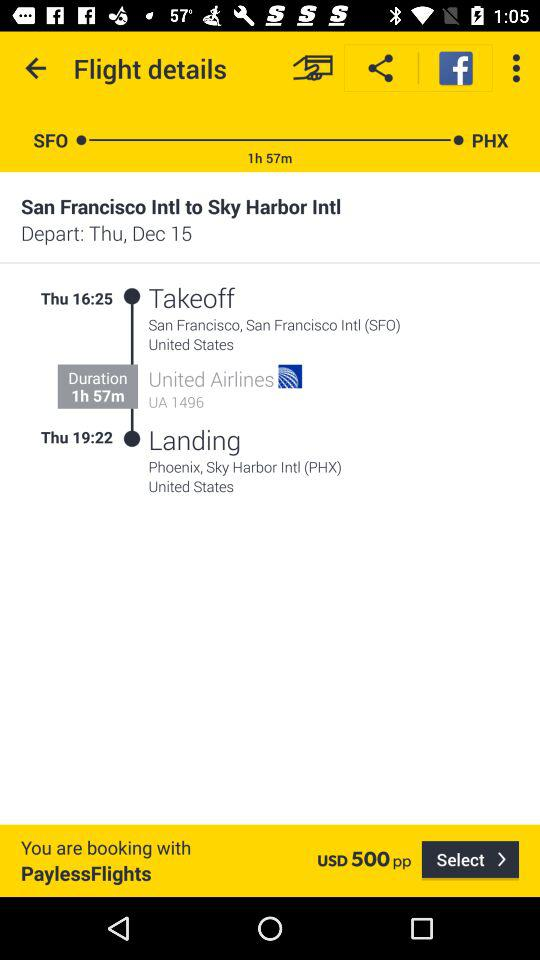How many hours does the flight take?
Answer the question using a single word or phrase. 1h 57m 